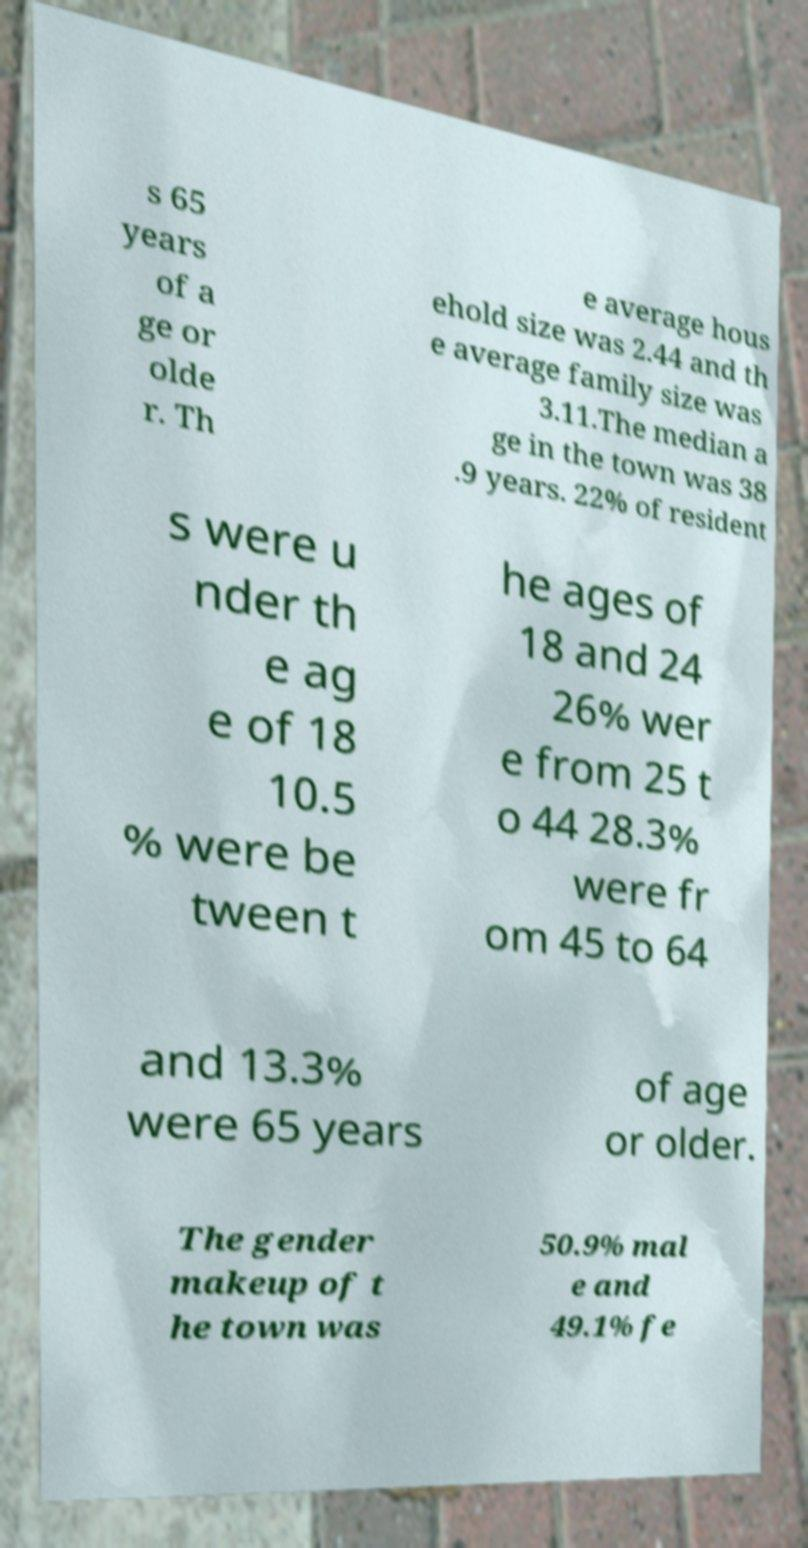Could you assist in decoding the text presented in this image and type it out clearly? s 65 years of a ge or olde r. Th e average hous ehold size was 2.44 and th e average family size was 3.11.The median a ge in the town was 38 .9 years. 22% of resident s were u nder th e ag e of 18 10.5 % were be tween t he ages of 18 and 24 26% wer e from 25 t o 44 28.3% were fr om 45 to 64 and 13.3% were 65 years of age or older. The gender makeup of t he town was 50.9% mal e and 49.1% fe 